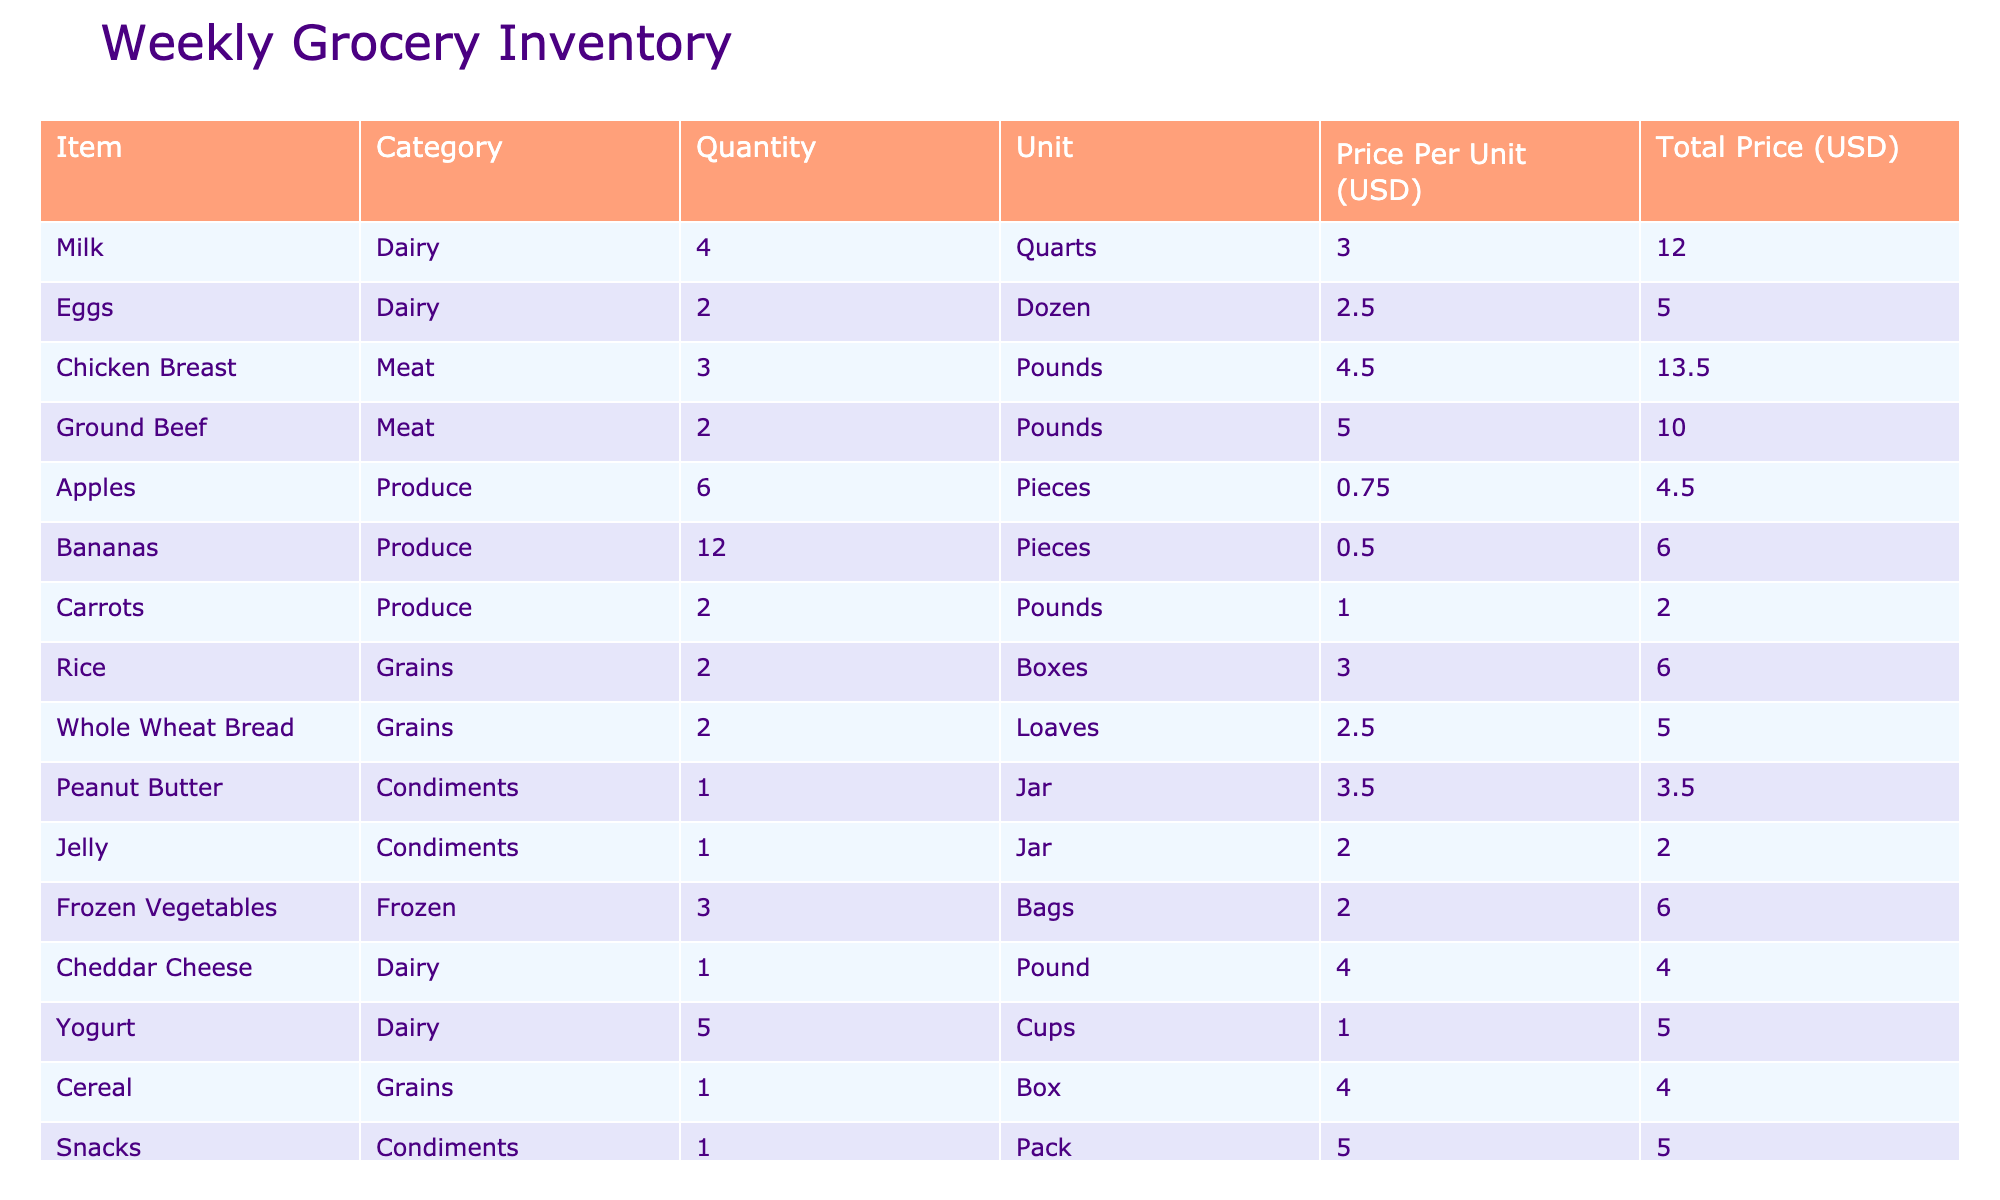What is the total quantity of dairy items in the inventory? There are three dairy items listed: Milk (4 Quarts), Eggs (2 Dozen), and Cheddar Cheese (1 Pound). To calculate the total, we add up the quantities: 4 + 2 + 1 = 7.
Answer: 7 How many pieces of fruit are in the inventory? The inventory has Apples (6 Pieces) and Bananas (12 Pieces). To find the total pieces of fruit, we add the two quantities: 6 + 12 = 18.
Answer: 18 Is there more meat or dairy in the inventory? There are three meat items: Chicken Breast (3 Pounds) and Ground Beef (2 Pounds), which sum to 5 Pounds of meat. The dairy items, as mentioned earlier, total 7. Since 5 is less than 7, there is more dairy than meat.
Answer: Yes What is the total price for all items in the inventory? We need to sum the total prices of all items. The total prices are: 12.00 + 5.00 + 13.50 + 10.00 + 4.50 + 6.00 + 2.00 + 6.00 + 5.00 + 3.50 + 2.00 + 6.00 + 4.00 + 5.00 + 5.00 = 78.50.
Answer: 78.50 What is the average price per unit of the Meat category? The Meat category includes Chicken Breast (4.50) and Ground Beef (5.00). To find the average price, we add the prices: 4.50 + 5.00 = 9.50, then divide by the number of items (2): 9.50 / 2 = 4.75.
Answer: 4.75 How many units of Condiments do we have in total? The Condiments category has three items: Peanut Butter (1 Jar), Jelly (1 Jar), and Snacks (1 Pack). To find the total, we add the quantities: 1 + 1 + 1 = 3.
Answer: 3 Which item in the inventory has the highest total price? To find the highest total price, we compare the total prices of each item. The prices are: Milk (12.00), Chicken Breast (13.50), Ground Beef (10.00), etc. Chicken Breast has the highest price at 13.50.
Answer: Chicken Breast Are there more boxes of rice or bags of frozen vegetables? Rice has 2 Boxes, and Frozen Vegetables have 3 Bags. Since 3 (frozen vegetables) is greater than 2 (rice), there are more bags of frozen vegetables.
Answer: Yes What is the total price of Produce items? The Produce items are Apples (4.50), Bananas (6.00), and Carrots (2.00). We add their total prices: 4.50 + 6.00 + 2.00 = 12.50.
Answer: 12.50 